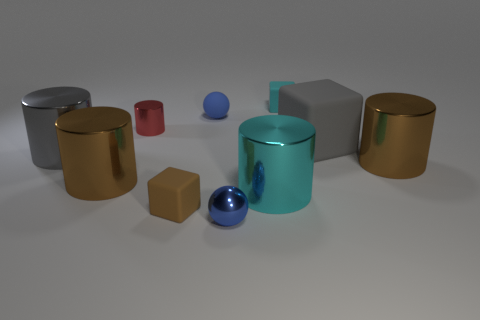Is there anything else of the same color as the tiny metallic cylinder?
Your response must be concise. No. Is the number of large cylinders that are behind the tiny cyan rubber thing the same as the number of big gray cylinders?
Provide a succinct answer. No. What number of cyan objects are on the left side of the tiny cube that is in front of the brown metallic object on the right side of the brown rubber thing?
Keep it short and to the point. 0. Are there any gray objects of the same size as the cyan cube?
Your response must be concise. No. Is the number of big shiny cylinders that are on the left side of the tiny red object less than the number of brown rubber things?
Your response must be concise. No. There is a small red cylinder behind the large gray object right of the small rubber cube that is in front of the tiny cyan matte cube; what is its material?
Offer a terse response. Metal. Are there more cylinders that are to the left of the matte sphere than tiny brown matte things behind the small red cylinder?
Provide a succinct answer. Yes. How many matte objects are tiny brown things or big things?
Offer a terse response. 2. There is a tiny object that is the same color as the rubber sphere; what is its shape?
Provide a short and direct response. Sphere. There is a large cube that is in front of the cyan cube; what is its material?
Your answer should be compact. Rubber. 